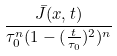<formula> <loc_0><loc_0><loc_500><loc_500>\frac { \bar { J } ( x , t ) } { \tau _ { 0 } ^ { n } ( 1 - ( \frac { t } { \tau _ { 0 } } ) ^ { 2 } ) ^ { n } }</formula> 